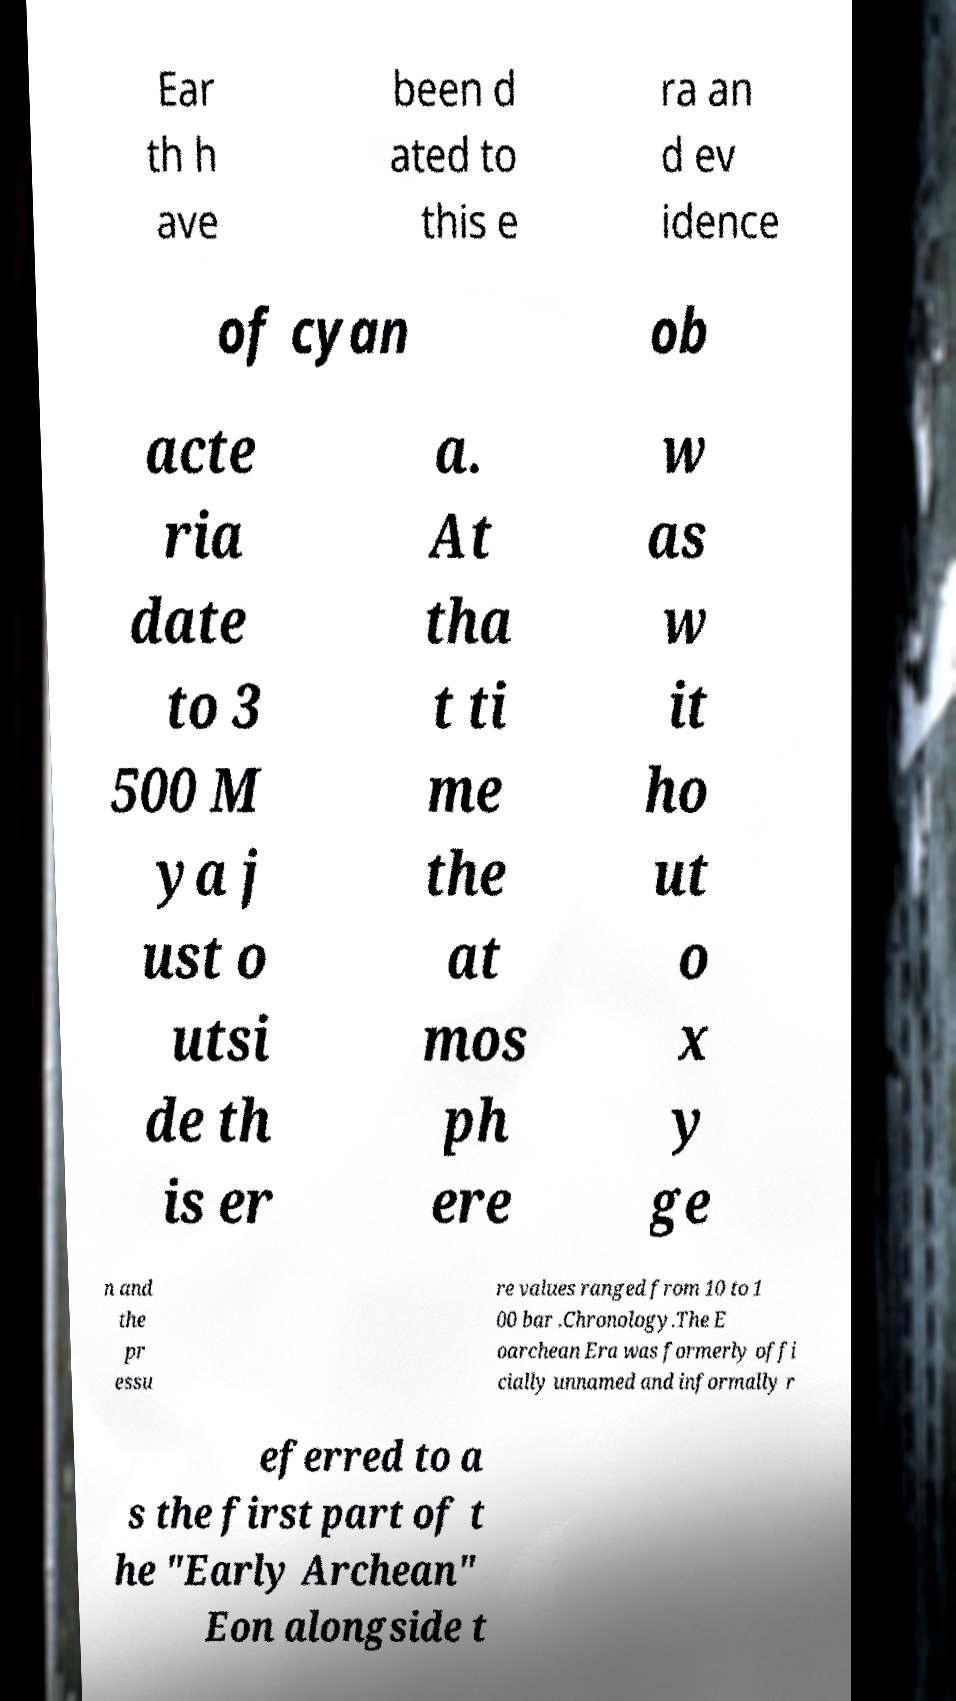Could you extract and type out the text from this image? Ear th h ave been d ated to this e ra an d ev idence of cyan ob acte ria date to 3 500 M ya j ust o utsi de th is er a. At tha t ti me the at mos ph ere w as w it ho ut o x y ge n and the pr essu re values ranged from 10 to 1 00 bar .Chronology.The E oarchean Era was formerly offi cially unnamed and informally r eferred to a s the first part of t he "Early Archean" Eon alongside t 